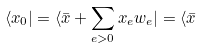<formula> <loc_0><loc_0><loc_500><loc_500>\langle x _ { 0 } | = \langle \bar { x } + \sum _ { e > 0 } x _ { e } w _ { e } | = \langle \bar { x }</formula> 